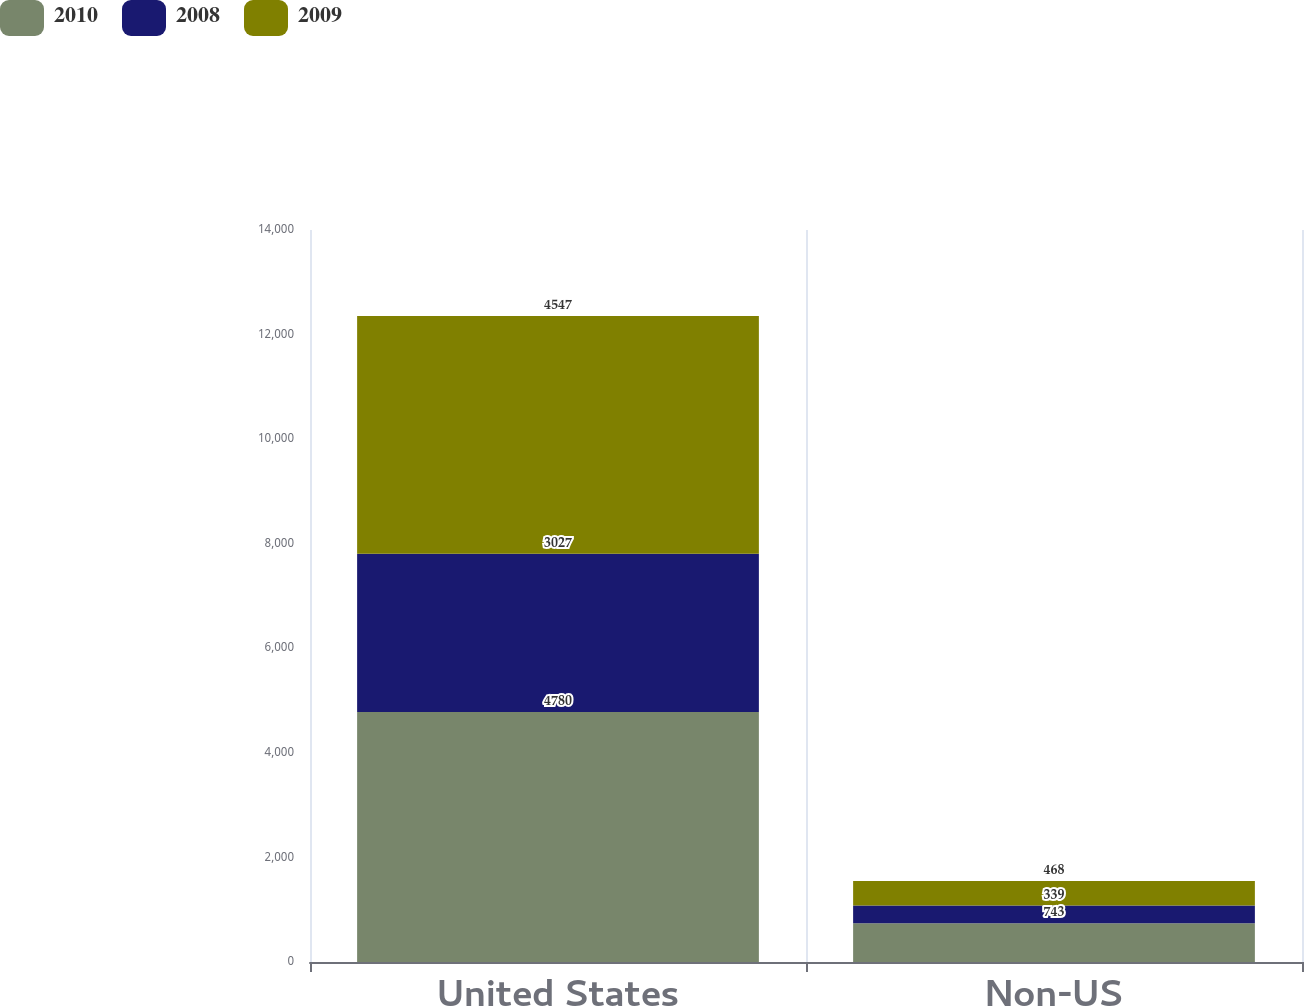Convert chart. <chart><loc_0><loc_0><loc_500><loc_500><stacked_bar_chart><ecel><fcel>United States<fcel>Non-US<nl><fcel>2010<fcel>4780<fcel>743<nl><fcel>2008<fcel>3027<fcel>339<nl><fcel>2009<fcel>4547<fcel>468<nl></chart> 